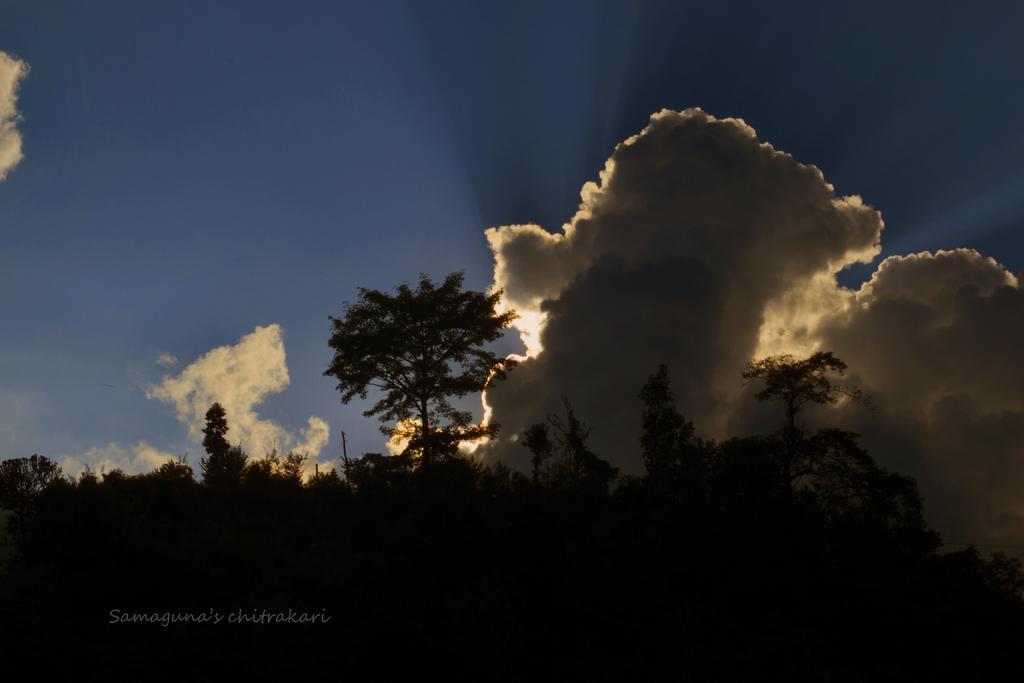Describe this image in one or two sentences. In the foreground of the picture I can see the trees. There are clouds in the sky. 